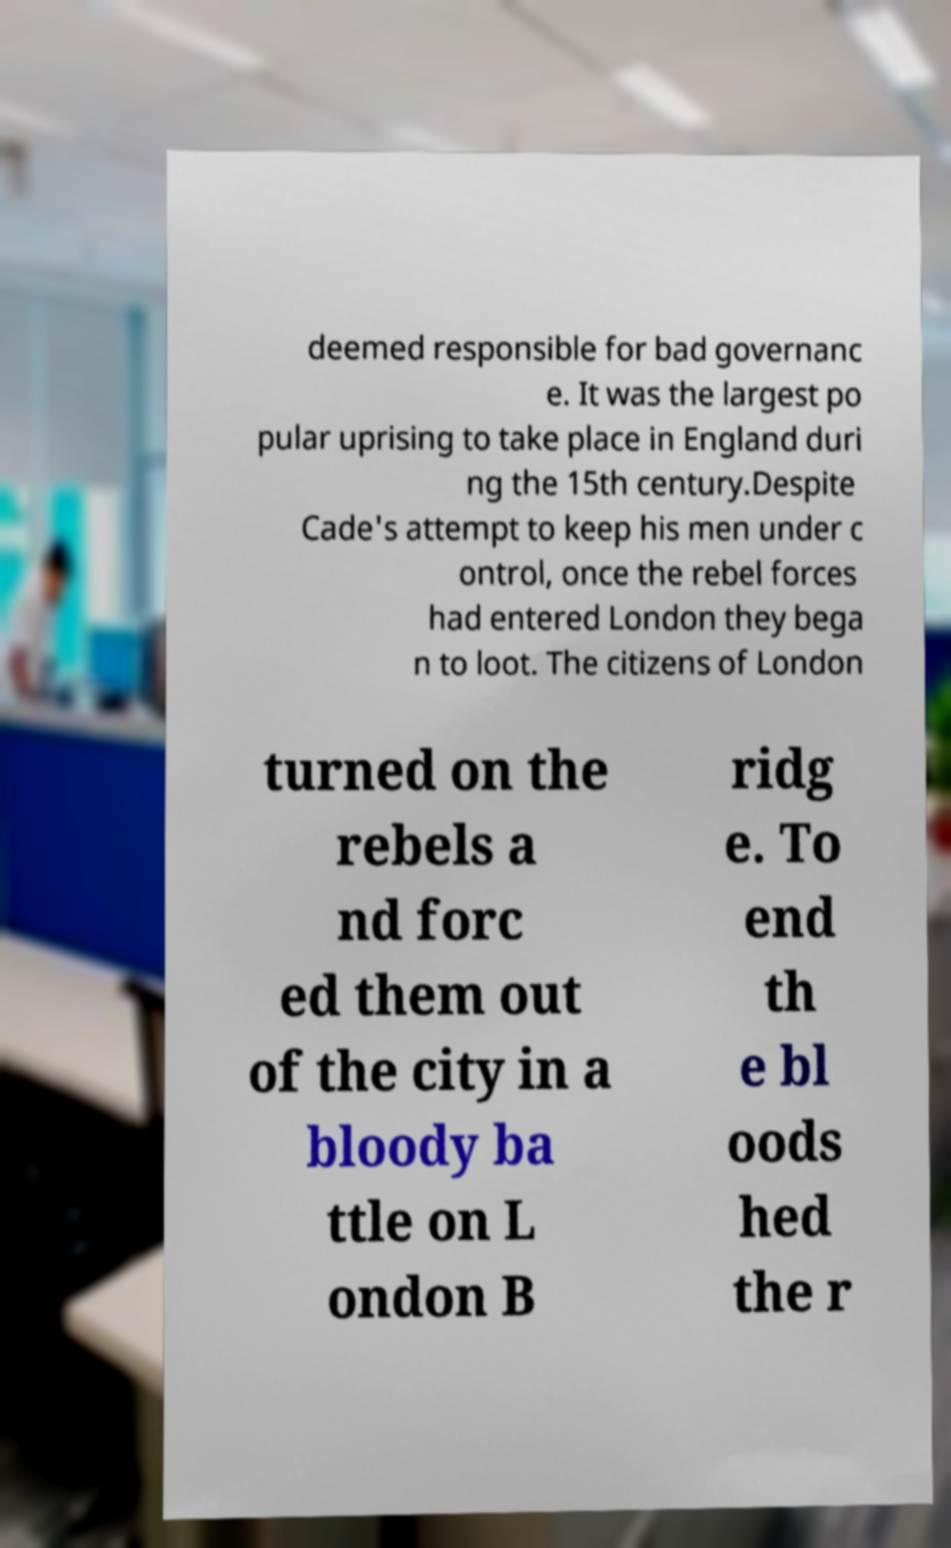There's text embedded in this image that I need extracted. Can you transcribe it verbatim? deemed responsible for bad governanc e. It was the largest po pular uprising to take place in England duri ng the 15th century.Despite Cade's attempt to keep his men under c ontrol, once the rebel forces had entered London they bega n to loot. The citizens of London turned on the rebels a nd forc ed them out of the city in a bloody ba ttle on L ondon B ridg e. To end th e bl oods hed the r 